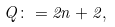Convert formula to latex. <formula><loc_0><loc_0><loc_500><loc_500>Q \colon = 2 n + 2 ,</formula> 